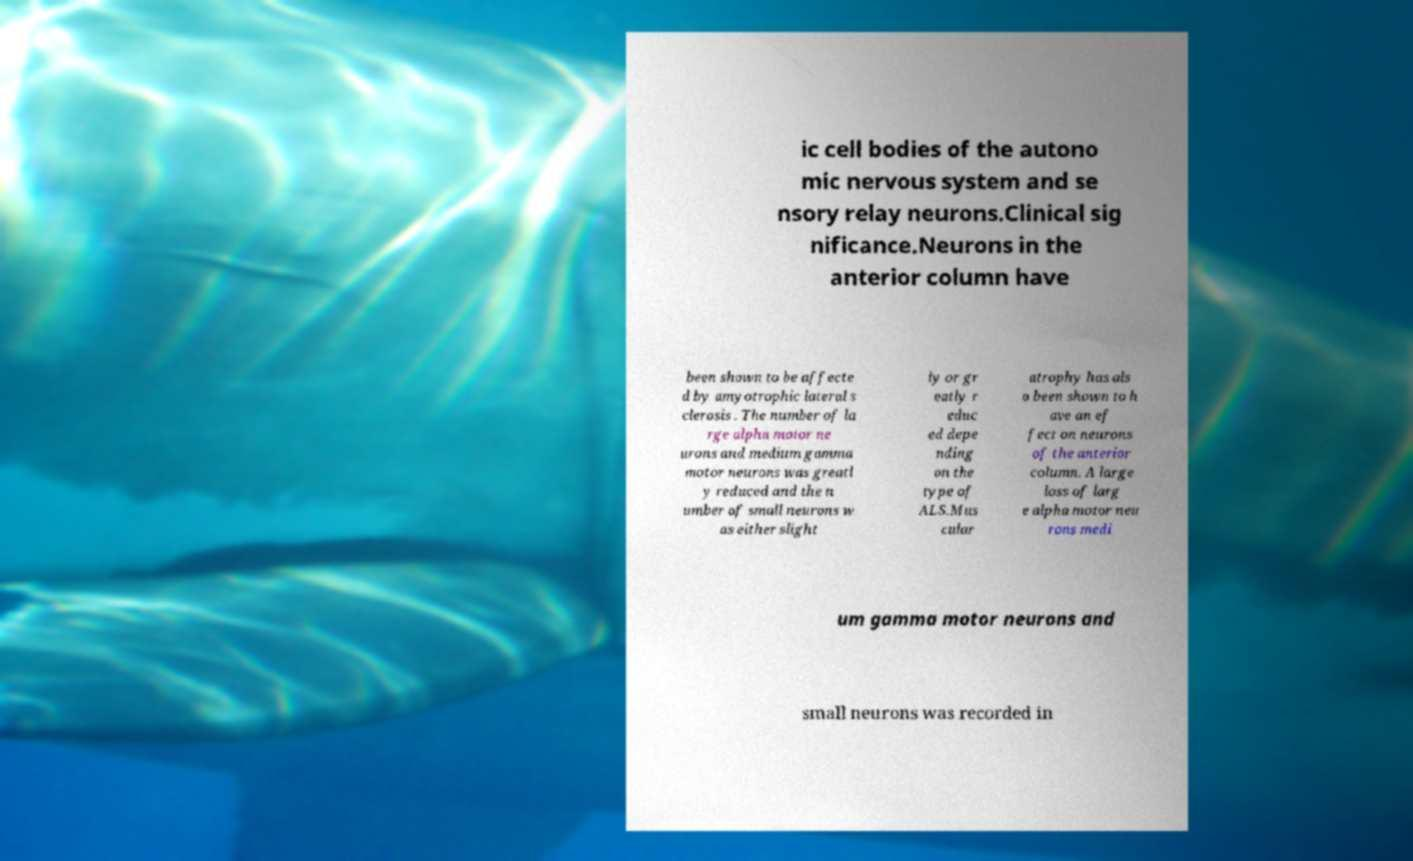There's text embedded in this image that I need extracted. Can you transcribe it verbatim? ic cell bodies of the autono mic nervous system and se nsory relay neurons.Clinical sig nificance.Neurons in the anterior column have been shown to be affecte d by amyotrophic lateral s clerosis . The number of la rge alpha motor ne urons and medium gamma motor neurons was greatl y reduced and the n umber of small neurons w as either slight ly or gr eatly r educ ed depe nding on the type of ALS.Mus cular atrophy has als o been shown to h ave an ef fect on neurons of the anterior column. A large loss of larg e alpha motor neu rons medi um gamma motor neurons and small neurons was recorded in 